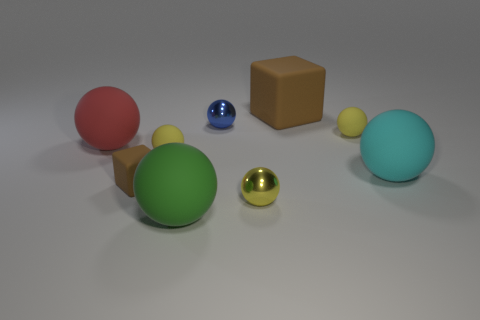What number of metal balls are the same color as the small rubber block?
Your response must be concise. 0. Is the number of large matte things that are behind the big green rubber sphere less than the number of cyan rubber things that are behind the small yellow metal sphere?
Make the answer very short. No. What is the size of the rubber block that is on the right side of the green object?
Your response must be concise. Large. What is the size of the other matte block that is the same color as the tiny cube?
Ensure brevity in your answer.  Large. Is there a large yellow thing that has the same material as the green ball?
Your answer should be compact. No. Does the large brown cube have the same material as the tiny cube?
Give a very brief answer. Yes. The matte cube that is the same size as the cyan matte object is what color?
Your answer should be compact. Brown. What number of other things are the same shape as the tiny brown thing?
Ensure brevity in your answer.  1. Do the green object and the yellow matte thing behind the red rubber thing have the same size?
Keep it short and to the point. No. How many objects are either small balls or large purple metallic cylinders?
Your response must be concise. 4. 